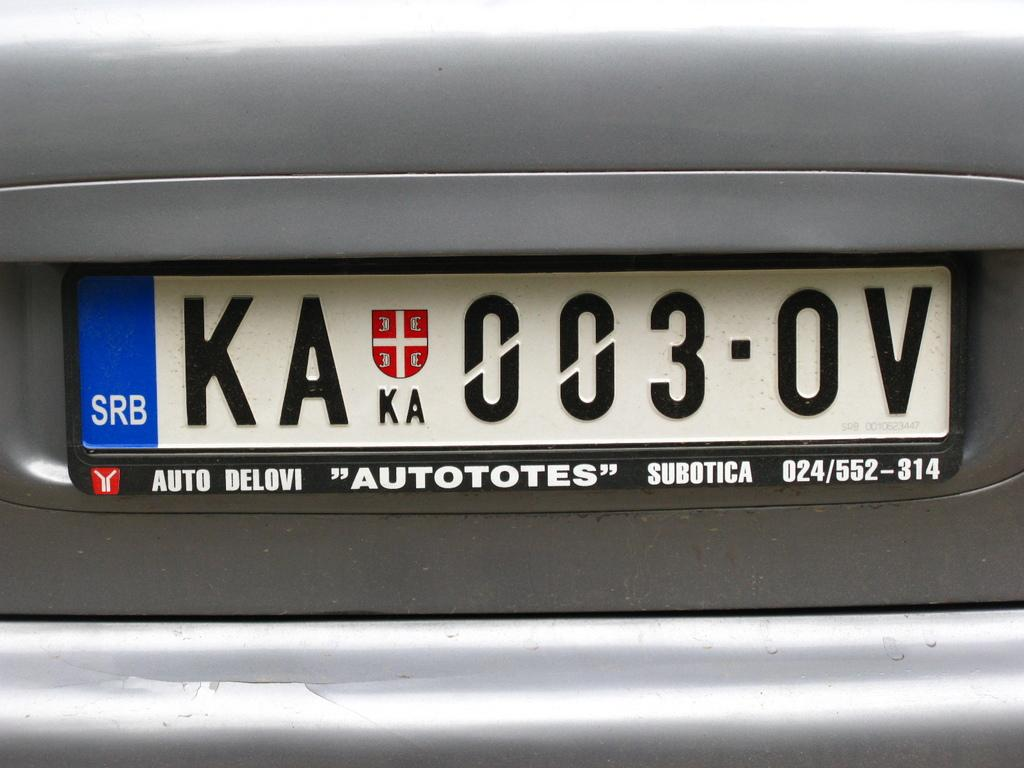<image>
Give a short and clear explanation of the subsequent image. The back of a car with license plate number KA 003 OV 